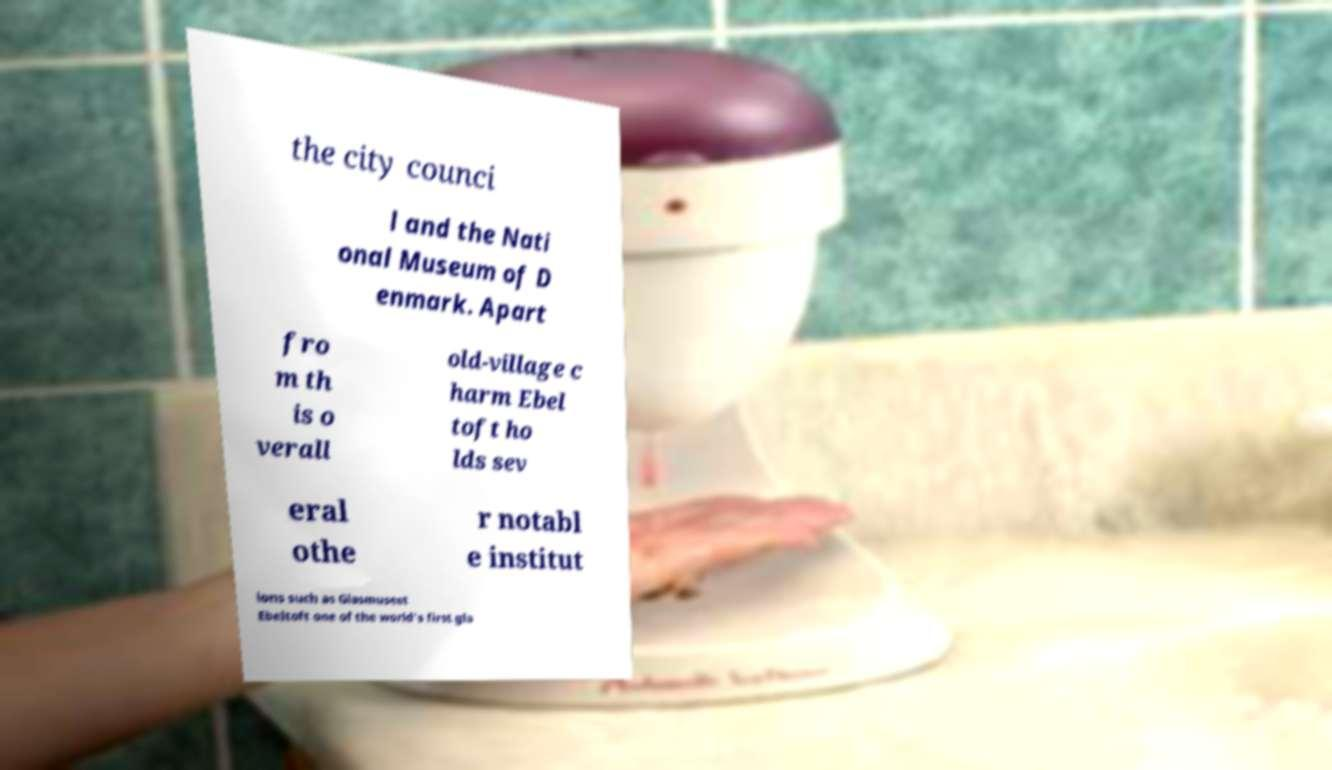I need the written content from this picture converted into text. Can you do that? the city counci l and the Nati onal Museum of D enmark. Apart fro m th is o verall old-village c harm Ebel toft ho lds sev eral othe r notabl e institut ions such as Glasmuseet Ebeltoft one of the world's first gla 